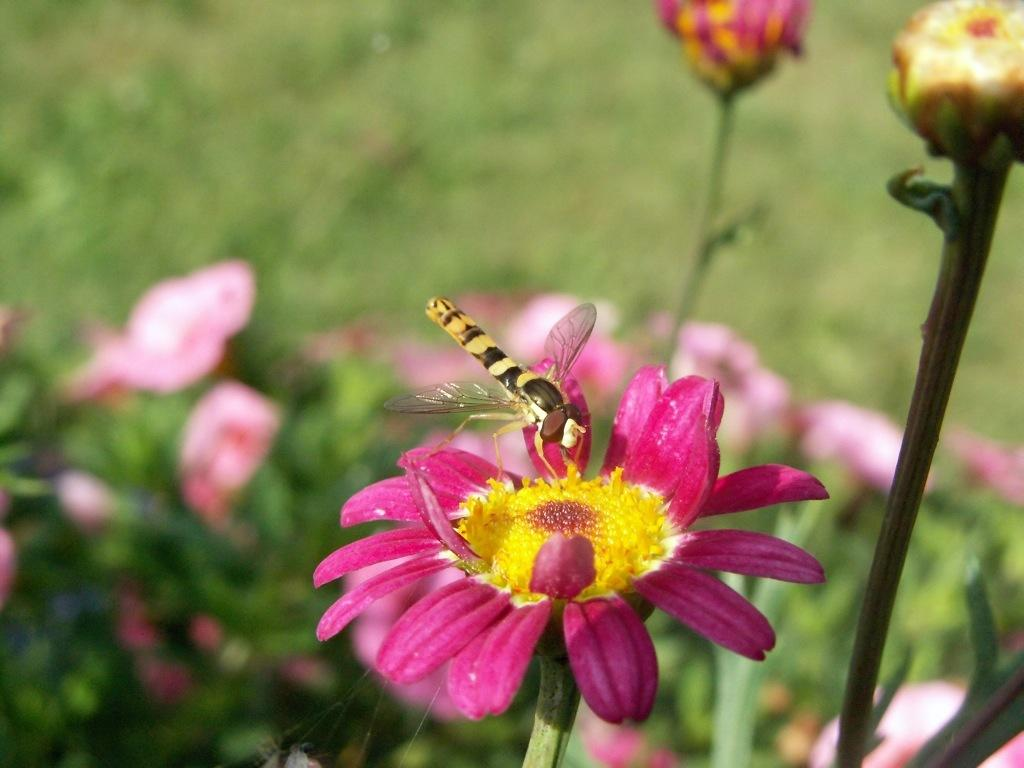What is the main subject of the image? The main subject of the image is a stem with a flower. Is there anything on the flower in the image? Yes, there is a dragonfly on the flower. What can be seen in the background of the image? There are flowers in the background of the image. How would you describe the appearance of the background? The background of the image is blurred. What type of credit card is visible in the image? There is no credit card present in the image; it features a stem with a flower and a dragonfly. Is the image framed in a circle? The image itself is not framed in a circle, as the provided facts do not mention any circular frame. 